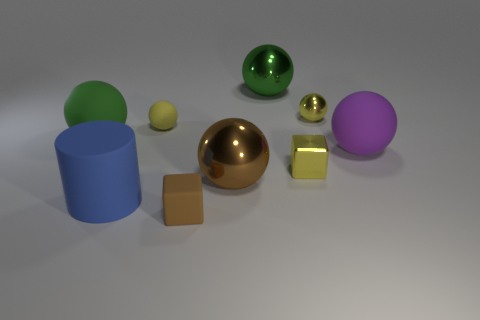Subtract all green balls. How many balls are left? 4 Subtract all tiny rubber balls. How many balls are left? 5 Subtract 3 balls. How many balls are left? 3 Subtract all red balls. Subtract all red cylinders. How many balls are left? 6 Add 1 large green objects. How many objects exist? 10 Subtract all cylinders. How many objects are left? 8 Add 1 shiny spheres. How many shiny spheres exist? 4 Subtract 0 gray blocks. How many objects are left? 9 Subtract all small cyan matte cylinders. Subtract all tiny yellow rubber things. How many objects are left? 8 Add 5 matte cubes. How many matte cubes are left? 6 